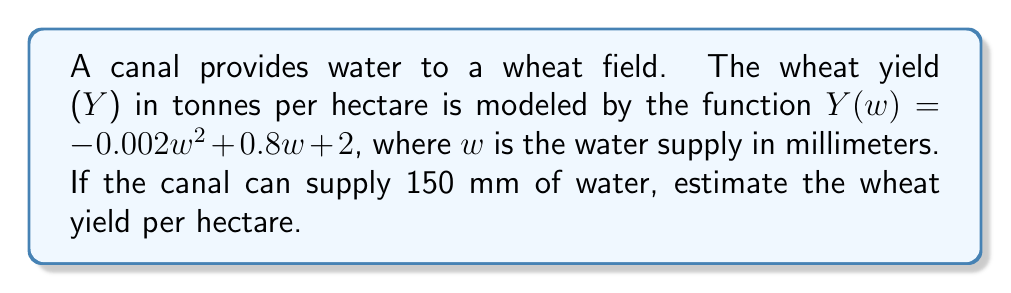Show me your answer to this math problem. To estimate the wheat yield based on the given water availability from the canal, we need to follow these steps:

1. Identify the given information:
   - The yield function is $Y(w) = -0.002w^2 + 0.8w + 2$
   - The water supply (w) from the canal is 150 mm

2. Substitute the water supply value into the yield function:
   $Y(150) = -0.002(150)^2 + 0.8(150) + 2$

3. Calculate the squared term:
   $Y(150) = -0.002(22500) + 0.8(150) + 2$

4. Multiply the coefficients:
   $Y(150) = -45 + 120 + 2$

5. Sum up the terms:
   $Y(150) = 77$

Therefore, with a water supply of 150 mm from the canal, the estimated wheat yield is 77 tonnes per hectare.
Answer: 77 tonnes/hectare 